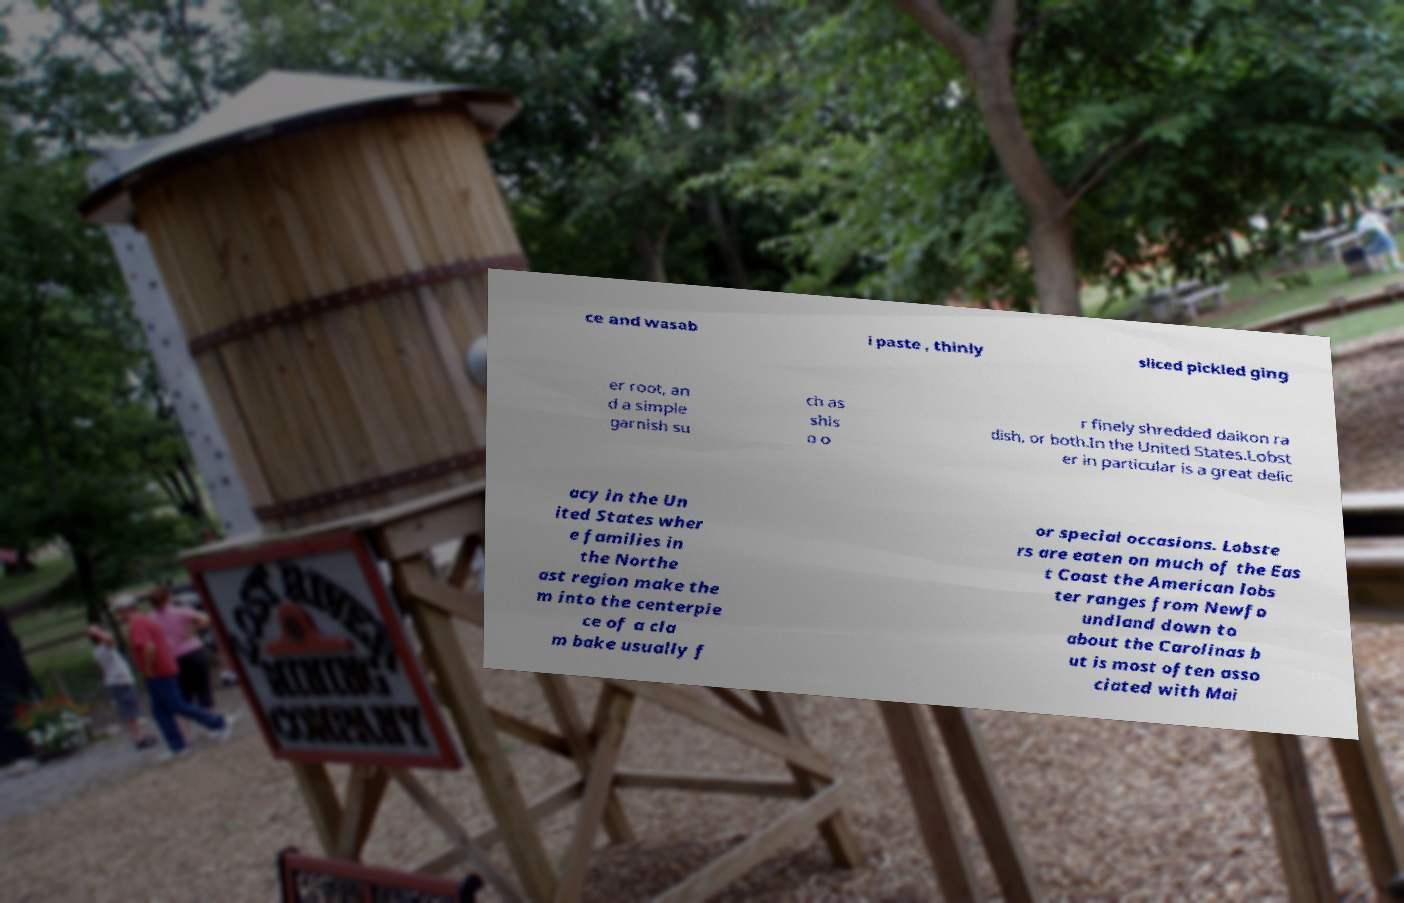Can you read and provide the text displayed in the image?This photo seems to have some interesting text. Can you extract and type it out for me? ce and wasab i paste , thinly sliced pickled ging er root, an d a simple garnish su ch as shis o o r finely shredded daikon ra dish, or both.In the United States.Lobst er in particular is a great delic acy in the Un ited States wher e families in the Northe ast region make the m into the centerpie ce of a cla m bake usually f or special occasions. Lobste rs are eaten on much of the Eas t Coast the American lobs ter ranges from Newfo undland down to about the Carolinas b ut is most often asso ciated with Mai 